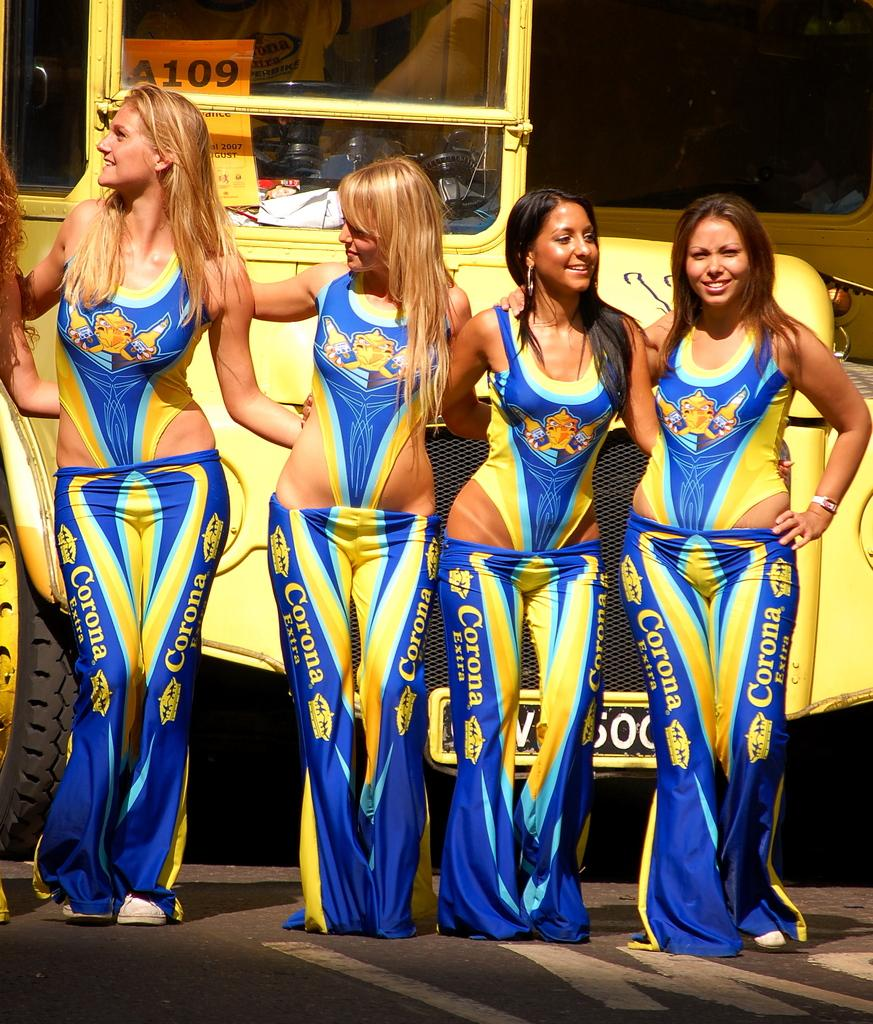<image>
Write a terse but informative summary of the picture. Four women wear swimsuits and blue and yellow Corona pants. 